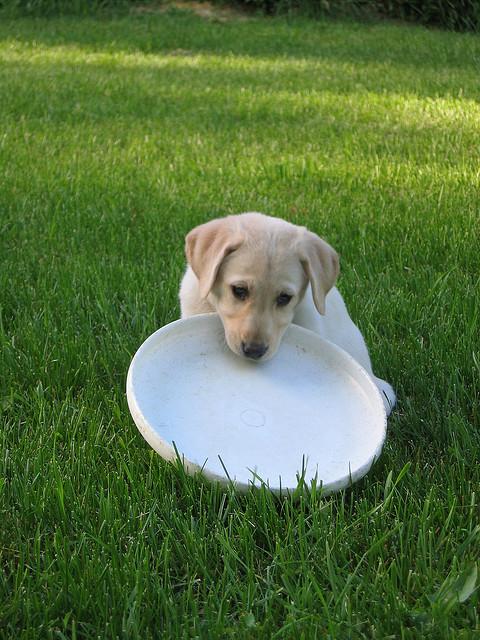What kind of dog is this?
Short answer required. Lab. What color is the frisbee?
Concise answer only. White. Does a woman throw the Frisbee?
Give a very brief answer. No. What breed of puppy is it?
Short answer required. Lab. Is the puppy small enough to lay inside the frisbee?
Give a very brief answer. Yes. Is the frisbee right side up?
Short answer required. No. 